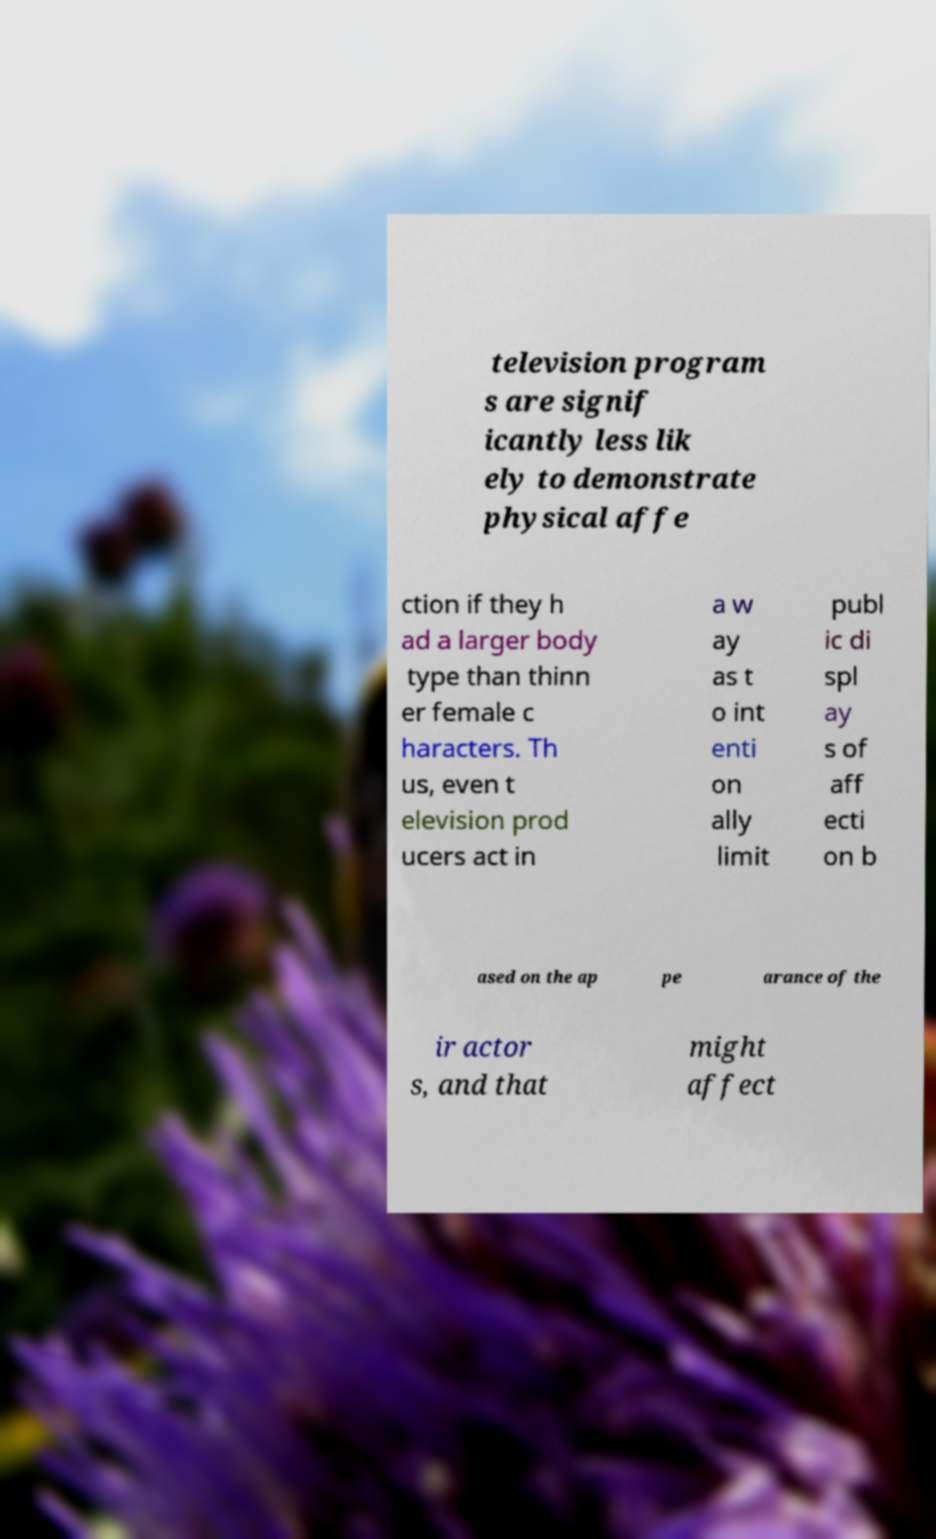For documentation purposes, I need the text within this image transcribed. Could you provide that? television program s are signif icantly less lik ely to demonstrate physical affe ction if they h ad a larger body type than thinn er female c haracters. Th us, even t elevision prod ucers act in a w ay as t o int enti on ally limit publ ic di spl ay s of aff ecti on b ased on the ap pe arance of the ir actor s, and that might affect 